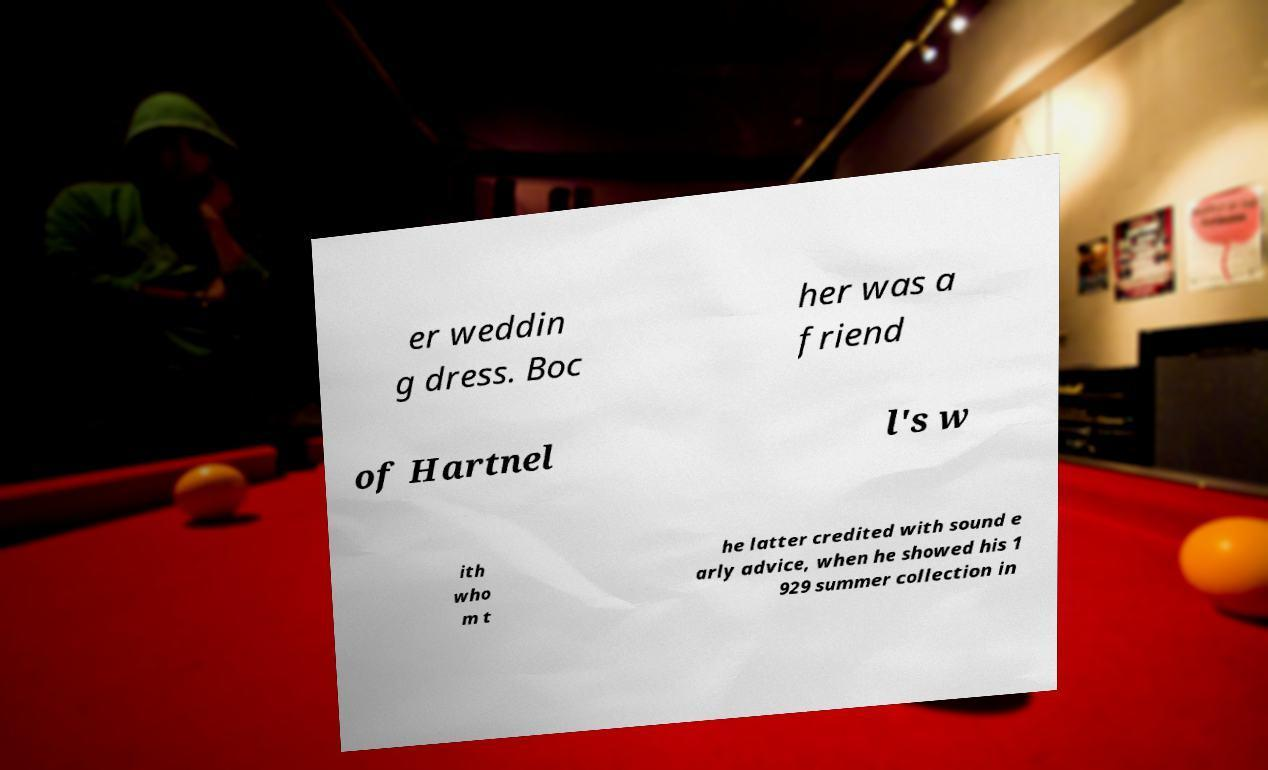For documentation purposes, I need the text within this image transcribed. Could you provide that? er weddin g dress. Boc her was a friend of Hartnel l's w ith who m t he latter credited with sound e arly advice, when he showed his 1 929 summer collection in 